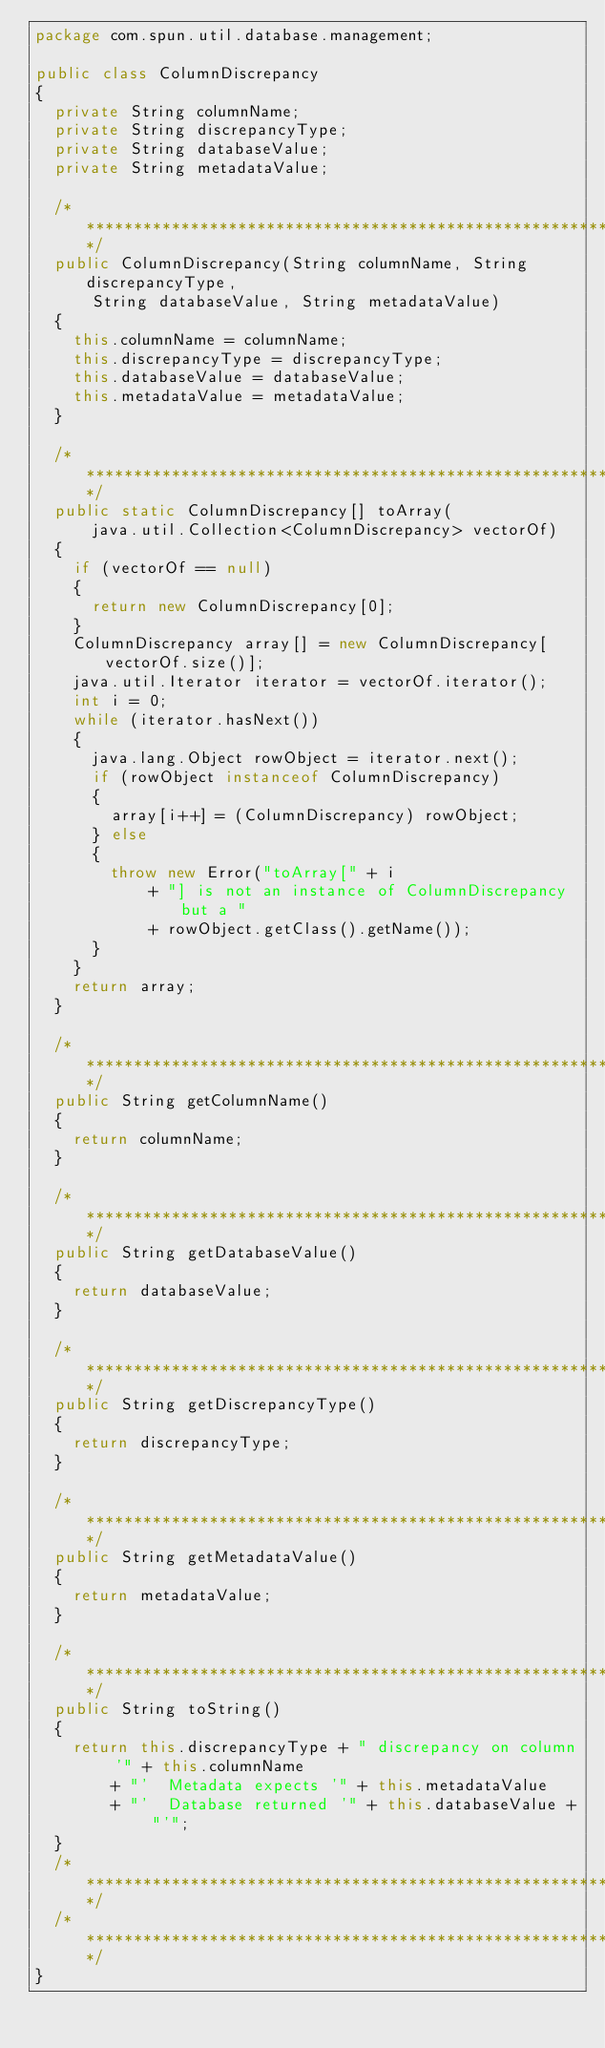<code> <loc_0><loc_0><loc_500><loc_500><_Java_>package com.spun.util.database.management;

public class ColumnDiscrepancy
{
  private String columnName;
  private String discrepancyType;
  private String databaseValue;
  private String metadataValue;

  /************************************************************************/
  public ColumnDiscrepancy(String columnName, String discrepancyType,
      String databaseValue, String metadataValue)
  {
    this.columnName = columnName;
    this.discrepancyType = discrepancyType;
    this.databaseValue = databaseValue;
    this.metadataValue = metadataValue;
  }

  /***********************************************************************/
  public static ColumnDiscrepancy[] toArray(
      java.util.Collection<ColumnDiscrepancy> vectorOf)
  {
    if (vectorOf == null)
    {
      return new ColumnDiscrepancy[0];
    }
    ColumnDiscrepancy array[] = new ColumnDiscrepancy[vectorOf.size()];
    java.util.Iterator iterator = vectorOf.iterator();
    int i = 0;
    while (iterator.hasNext())
    {
      java.lang.Object rowObject = iterator.next();
      if (rowObject instanceof ColumnDiscrepancy)
      {
        array[i++] = (ColumnDiscrepancy) rowObject;
      } else
      {
        throw new Error("toArray[" + i
            + "] is not an instance of ColumnDiscrepancy but a "
            + rowObject.getClass().getName());
      }
    }
    return array;
  }

  /************************************************************************/
  public String getColumnName()
  {
    return columnName;
  }

  /************************************************************************/
  public String getDatabaseValue()
  {
    return databaseValue;
  }

  /************************************************************************/
  public String getDiscrepancyType()
  {
    return discrepancyType;
  }

  /************************************************************************/
  public String getMetadataValue()
  {
    return metadataValue;
  }

  /***********************************************************************/
  public String toString()
  {
    return this.discrepancyType + " discrepancy on column '" + this.columnName
        + "'  Metadata expects '" + this.metadataValue
        + "'  Database returned '" + this.databaseValue + "'";
  }
  /************************************************************************/
  /************************************************************************/
}</code> 